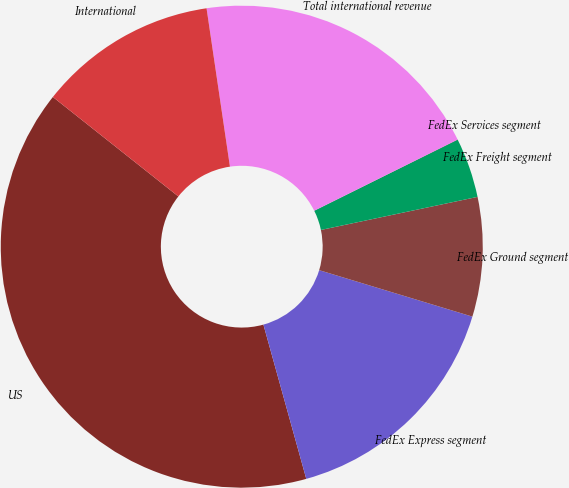Convert chart. <chart><loc_0><loc_0><loc_500><loc_500><pie_chart><fcel>US<fcel>FedEx Express segment<fcel>FedEx Ground segment<fcel>FedEx Freight segment<fcel>FedEx Services segment<fcel>Total international revenue<fcel>International<nl><fcel>39.98%<fcel>16.0%<fcel>8.0%<fcel>4.01%<fcel>0.01%<fcel>20.0%<fcel>12.0%<nl></chart> 